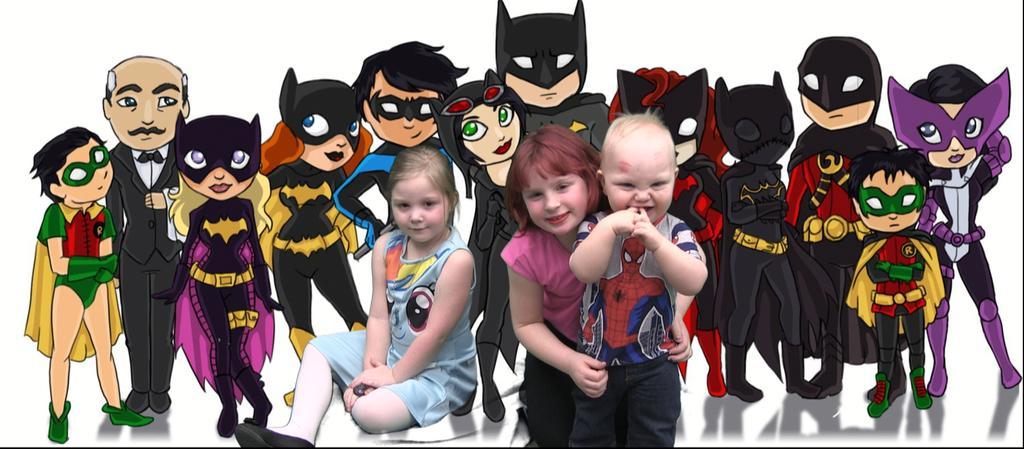Please provide a concise description of this image. This is an edited picture where we can see cartoon in the background and in the front, there are two girls and a boy posing to the camera. 